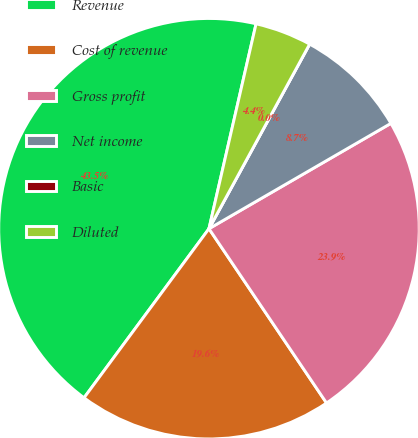Convert chart. <chart><loc_0><loc_0><loc_500><loc_500><pie_chart><fcel>Revenue<fcel>Cost of revenue<fcel>Gross profit<fcel>Net income<fcel>Basic<fcel>Diluted<nl><fcel>43.47%<fcel>19.57%<fcel>23.91%<fcel>8.7%<fcel>0.0%<fcel>4.35%<nl></chart> 